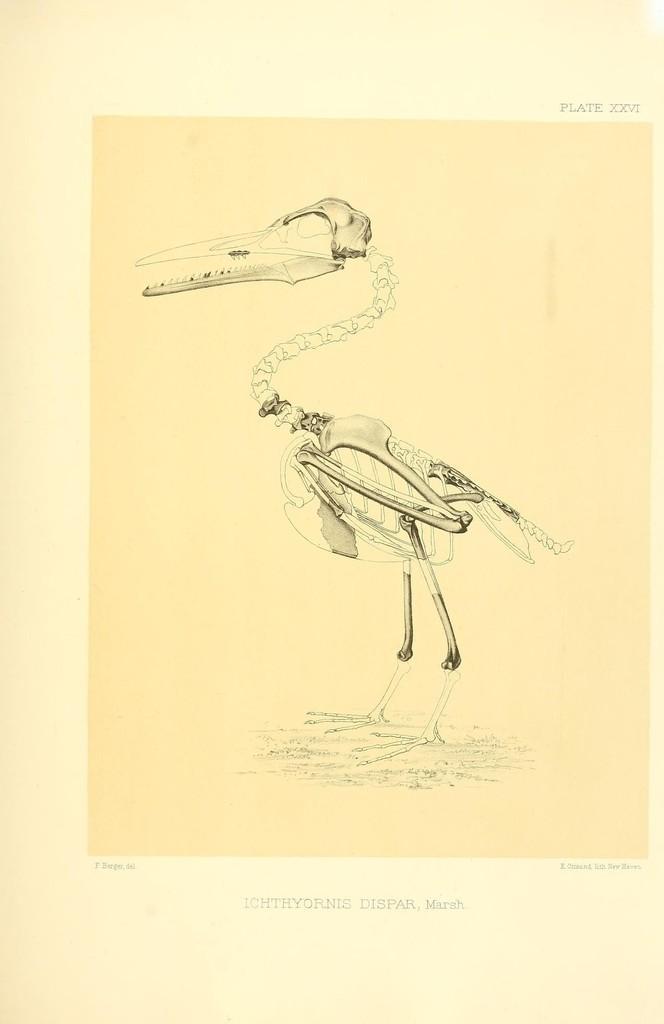Could you give a brief overview of what you see in this image? In the picture there is a skeleton image of a bird. 